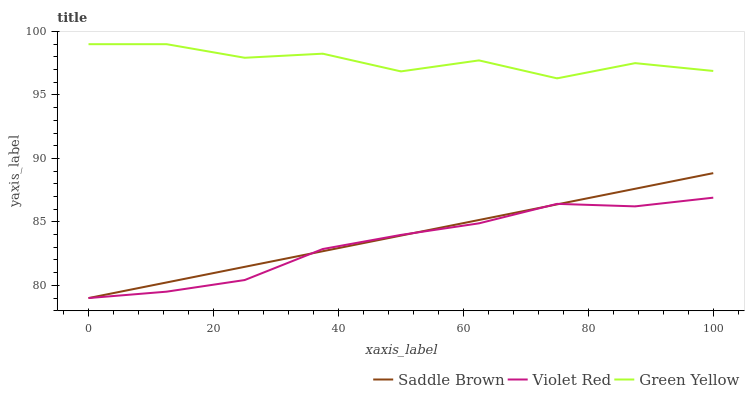Does Violet Red have the minimum area under the curve?
Answer yes or no. Yes. Does Green Yellow have the maximum area under the curve?
Answer yes or no. Yes. Does Saddle Brown have the minimum area under the curve?
Answer yes or no. No. Does Saddle Brown have the maximum area under the curve?
Answer yes or no. No. Is Saddle Brown the smoothest?
Answer yes or no. Yes. Is Green Yellow the roughest?
Answer yes or no. Yes. Is Green Yellow the smoothest?
Answer yes or no. No. Is Saddle Brown the roughest?
Answer yes or no. No. Does Violet Red have the lowest value?
Answer yes or no. Yes. Does Green Yellow have the lowest value?
Answer yes or no. No. Does Green Yellow have the highest value?
Answer yes or no. Yes. Does Saddle Brown have the highest value?
Answer yes or no. No. Is Violet Red less than Green Yellow?
Answer yes or no. Yes. Is Green Yellow greater than Saddle Brown?
Answer yes or no. Yes. Does Violet Red intersect Saddle Brown?
Answer yes or no. Yes. Is Violet Red less than Saddle Brown?
Answer yes or no. No. Is Violet Red greater than Saddle Brown?
Answer yes or no. No. Does Violet Red intersect Green Yellow?
Answer yes or no. No. 